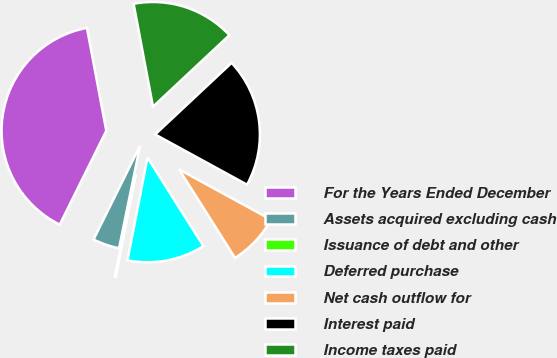Convert chart. <chart><loc_0><loc_0><loc_500><loc_500><pie_chart><fcel>For the Years Ended December<fcel>Assets acquired excluding cash<fcel>Issuance of debt and other<fcel>Deferred purchase<fcel>Net cash outflow for<fcel>Interest paid<fcel>Income taxes paid<nl><fcel>39.71%<fcel>4.11%<fcel>0.16%<fcel>12.03%<fcel>8.07%<fcel>19.94%<fcel>15.98%<nl></chart> 